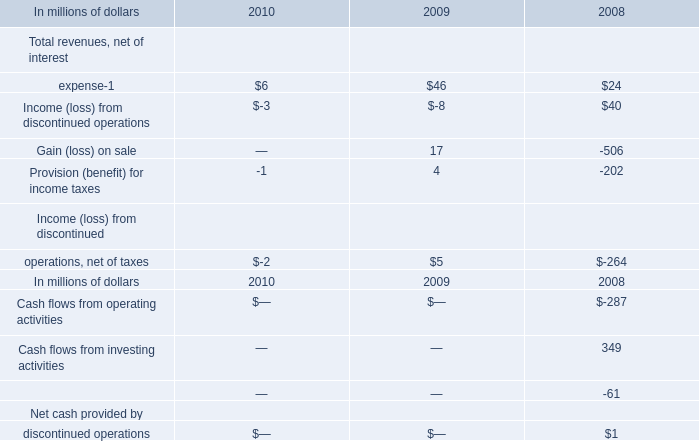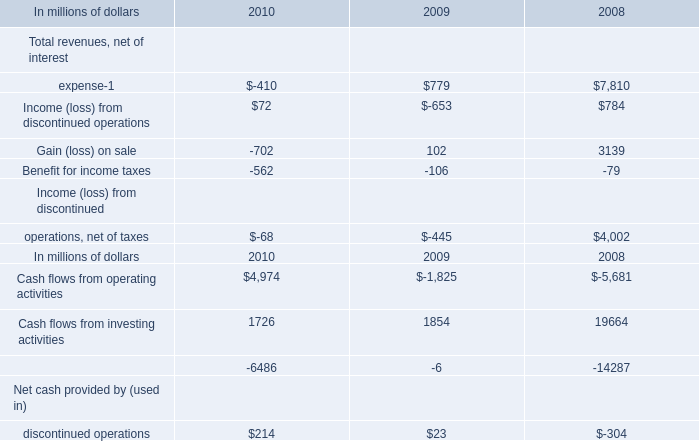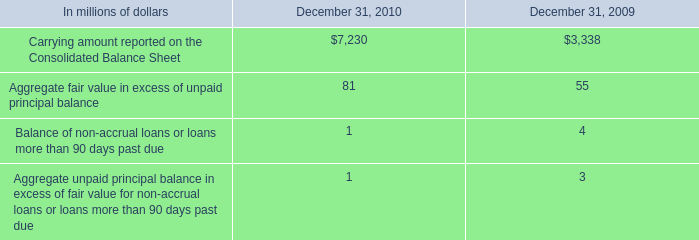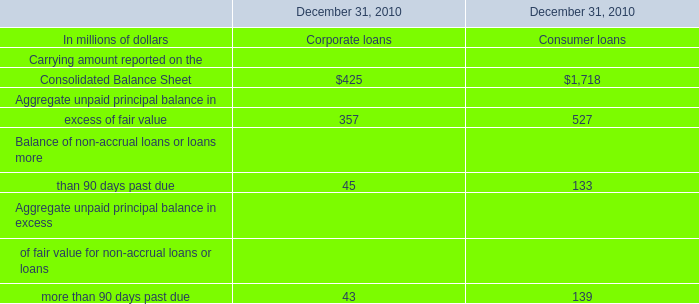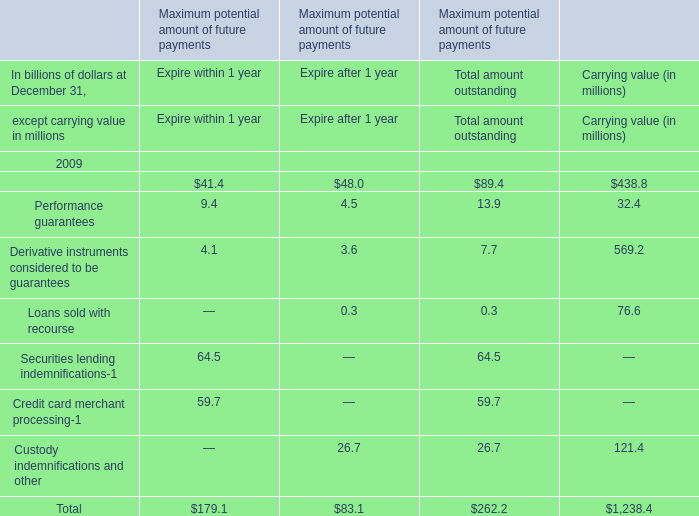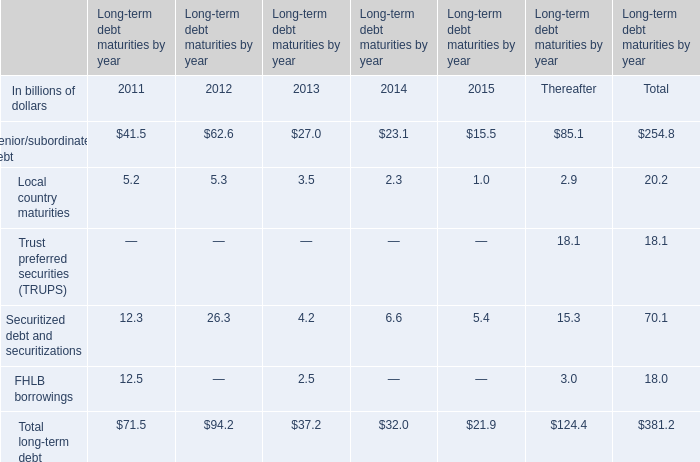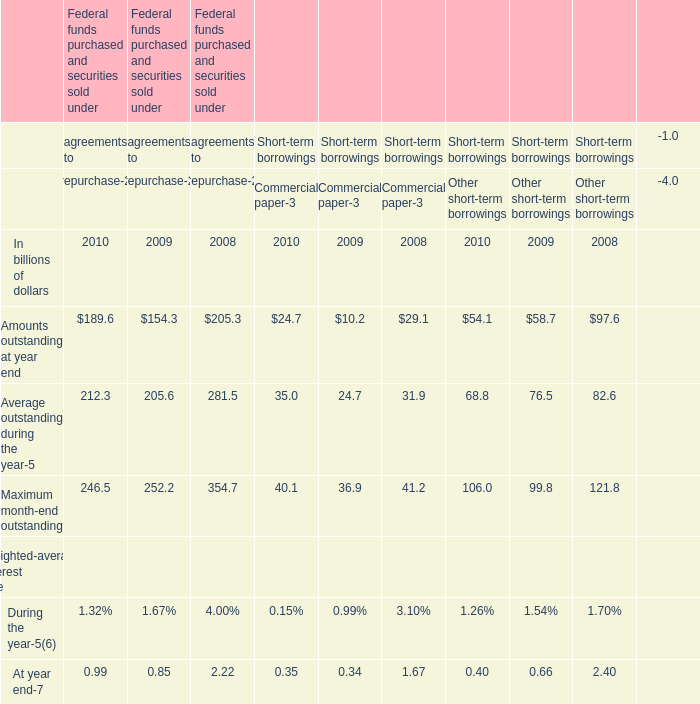What was the total amount of Senior/subordinated debt greater than 40 in 2011 ? (in billion) 
Answer: 41.5. 